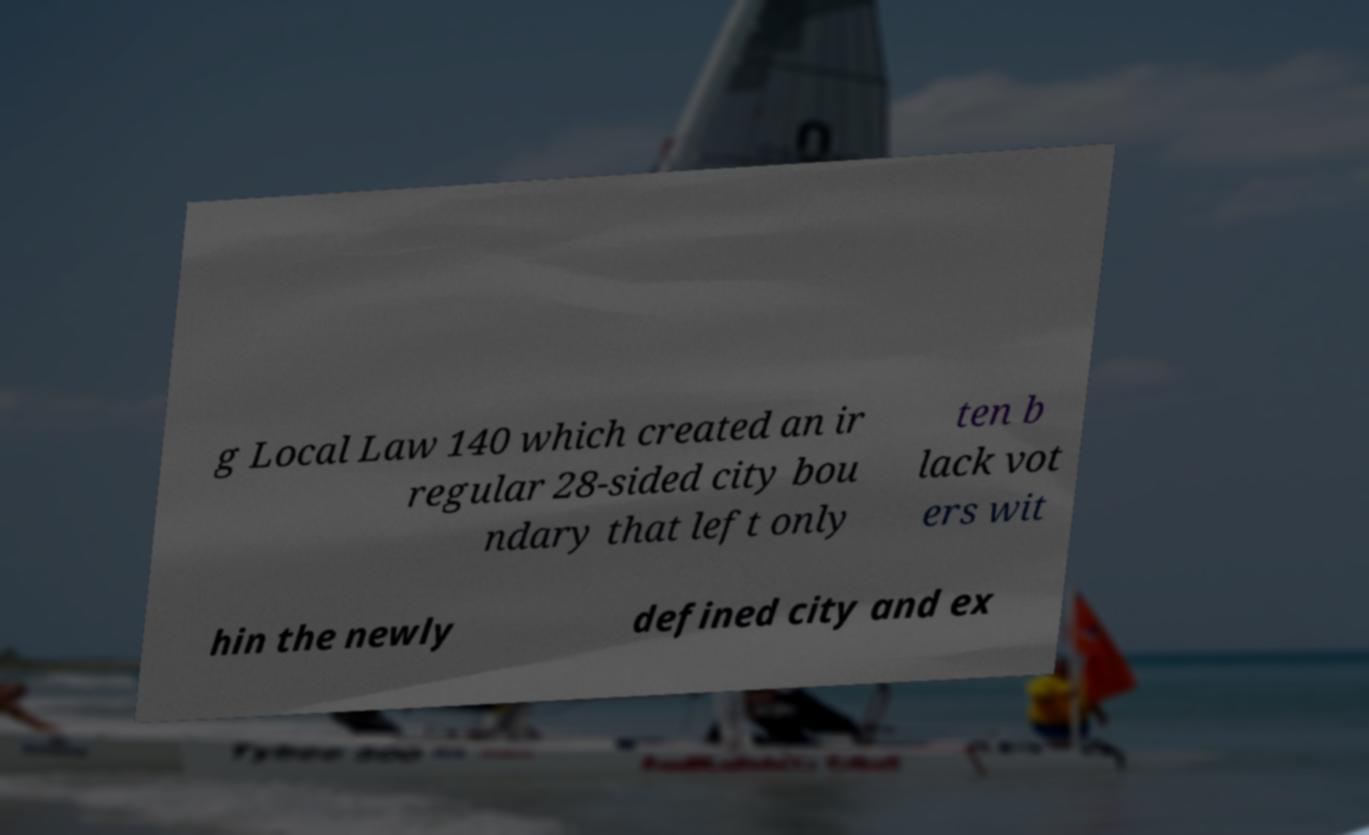Can you read and provide the text displayed in the image?This photo seems to have some interesting text. Can you extract and type it out for me? g Local Law 140 which created an ir regular 28-sided city bou ndary that left only ten b lack vot ers wit hin the newly defined city and ex 